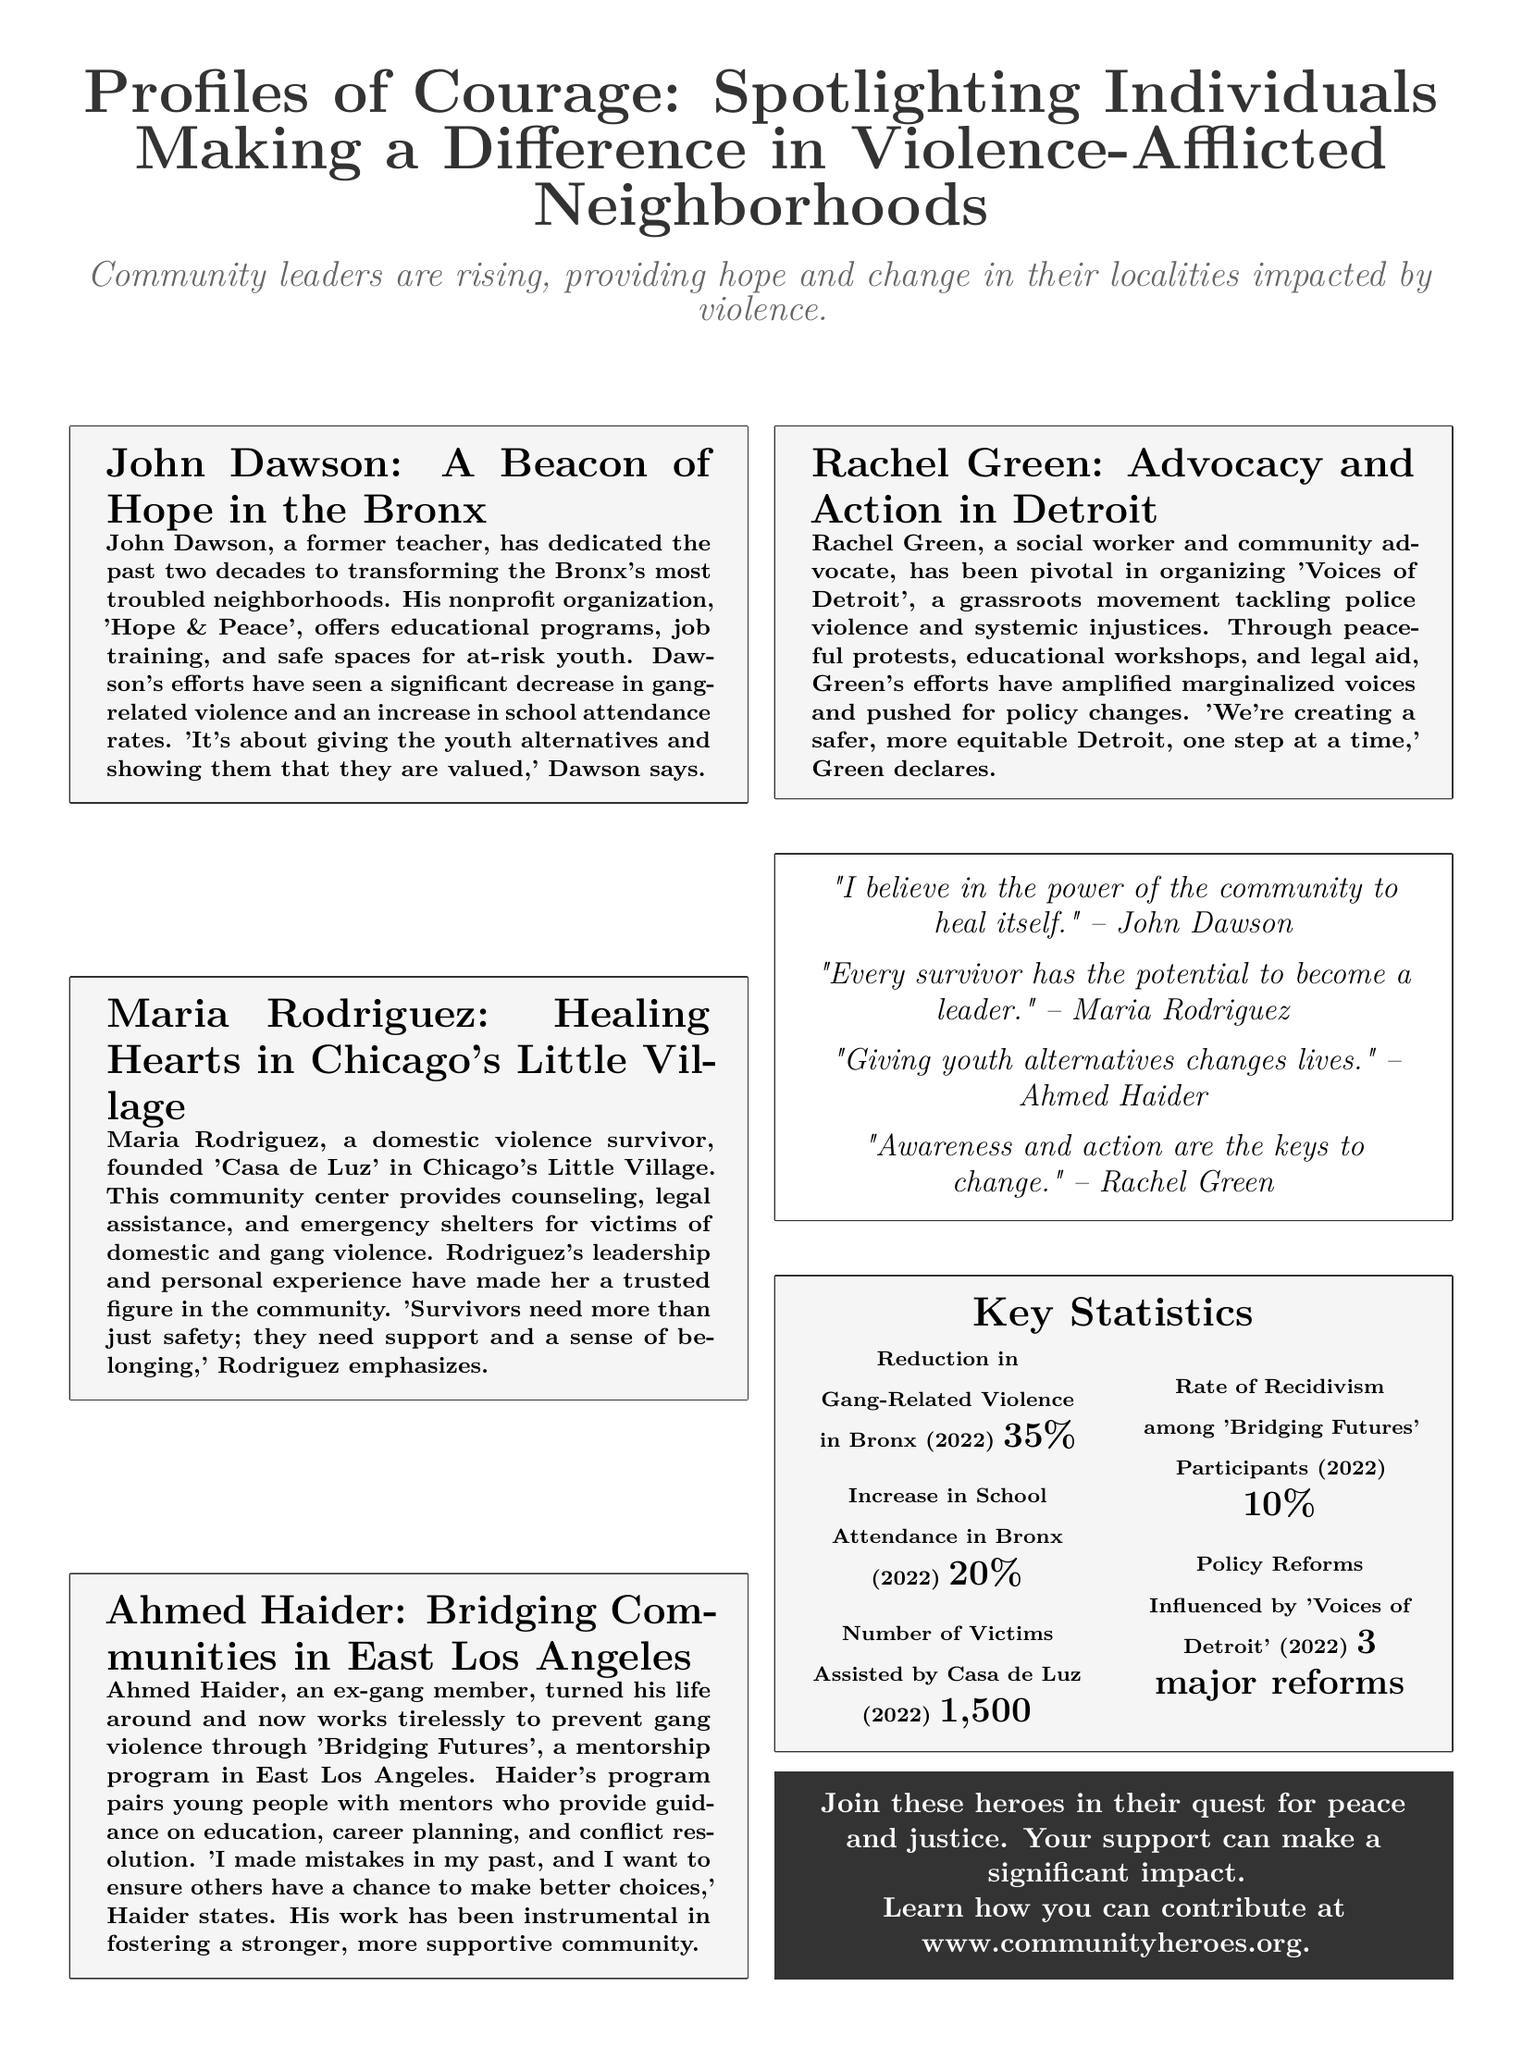What is the name of the community center founded by Maria Rodriguez? The document mentions that Maria Rodriguez founded the community center 'Casa de Luz' in Chicago's Little Village.
Answer: Casa de Luz What is the primary focus of John Dawson's organization? The article states that John Dawson's nonprofit organization 'Hope & Peace' focuses on educational programs, job training, and safe spaces for at-risk youth.
Answer: Educational programs What did Rachel Green advocate for in 'Voices of Detroit'? Rachel Green is noted to be pivotal in advocating against police violence and systemic injustices through the grassroots movement 'Voices of Detroit'.
Answer: Police violence What is the reduction percentage of gang-related violence in the Bronx in 2022? The document provides a statistic showing a 35% reduction in gang-related violence in the Bronx for the year 2022.
Answer: 35% What is the number of victims assisted by Casa de Luz in 2022? According to the key statistics section, Casa de Luz assisted 1,500 victims in 2022.
Answer: 1,500 What is Ahmed Haider's past profession? Ahmed Haider is described as an ex-gang member who turned his life around.
Answer: Ex-gang member What does Maria Rodriguez emphasize is needed by survivors? Maria Rodriguez emphasizes that survivors of violence need support and a sense of belonging in addition to safety.
Answer: Support and a sense of belonging What percentage of youth involved in 'Bridging Futures' had recidivism in 2022? The document states that the rate of recidivism among 'Bridging Futures' participants was 10% in 2022.
Answer: 10% How many major reforms were influenced by 'Voices of Detroit' in 2022? It is noted that 'Voices of Detroit' influenced three major reforms in the year 2022.
Answer: 3 major reforms 